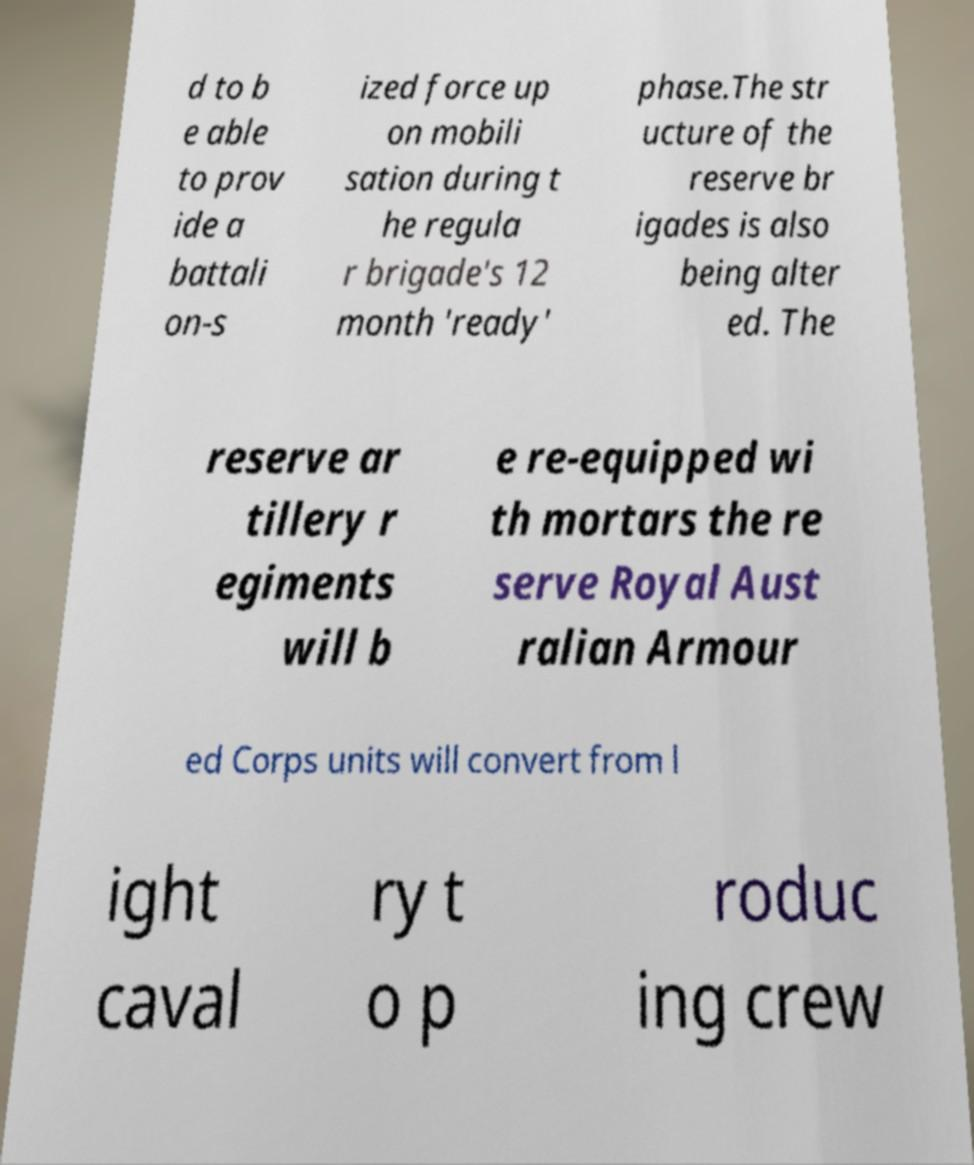Please read and relay the text visible in this image. What does it say? d to b e able to prov ide a battali on-s ized force up on mobili sation during t he regula r brigade's 12 month 'ready' phase.The str ucture of the reserve br igades is also being alter ed. The reserve ar tillery r egiments will b e re-equipped wi th mortars the re serve Royal Aust ralian Armour ed Corps units will convert from l ight caval ry t o p roduc ing crew 